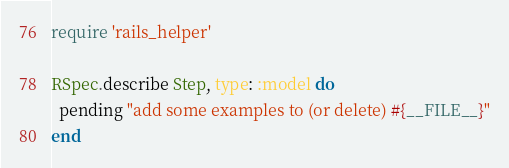Convert code to text. <code><loc_0><loc_0><loc_500><loc_500><_Ruby_>require 'rails_helper'

RSpec.describe Step, type: :model do
  pending "add some examples to (or delete) #{__FILE__}"
end
</code> 